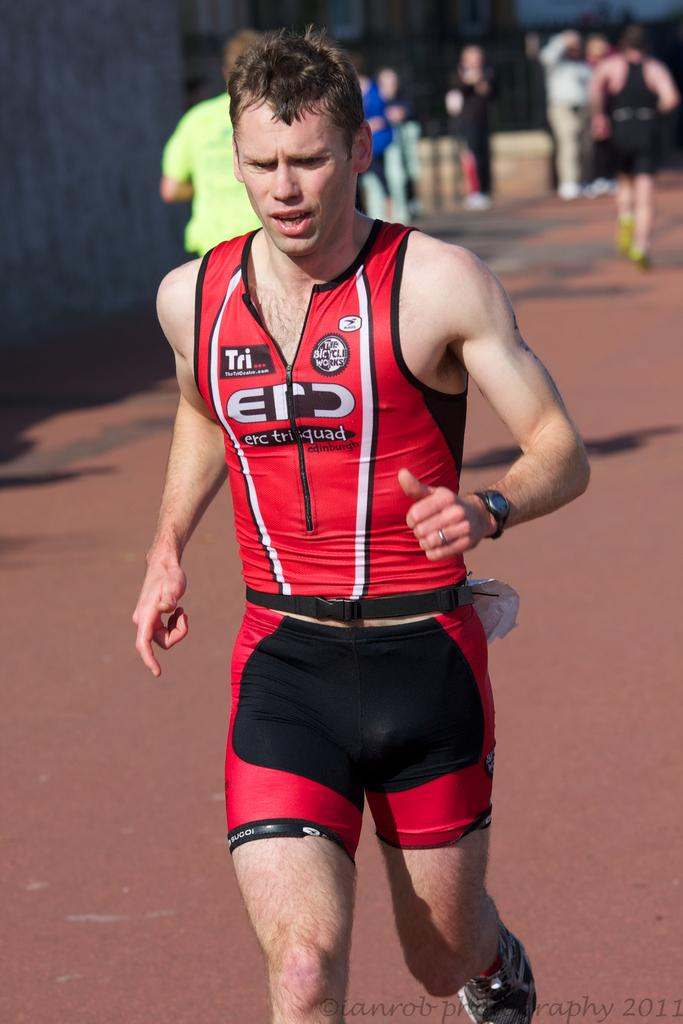<image>
Give a short and clear explanation of the subsequent image. A man wearing an Erc Trisquad uniform is runnning. 